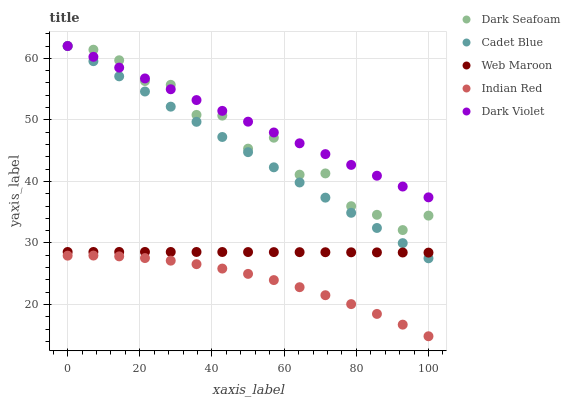Does Indian Red have the minimum area under the curve?
Answer yes or no. Yes. Does Dark Violet have the maximum area under the curve?
Answer yes or no. Yes. Does Cadet Blue have the minimum area under the curve?
Answer yes or no. No. Does Cadet Blue have the maximum area under the curve?
Answer yes or no. No. Is Cadet Blue the smoothest?
Answer yes or no. Yes. Is Dark Seafoam the roughest?
Answer yes or no. Yes. Is Web Maroon the smoothest?
Answer yes or no. No. Is Web Maroon the roughest?
Answer yes or no. No. Does Indian Red have the lowest value?
Answer yes or no. Yes. Does Cadet Blue have the lowest value?
Answer yes or no. No. Does Dark Violet have the highest value?
Answer yes or no. Yes. Does Web Maroon have the highest value?
Answer yes or no. No. Is Indian Red less than Web Maroon?
Answer yes or no. Yes. Is Web Maroon greater than Indian Red?
Answer yes or no. Yes. Does Dark Violet intersect Dark Seafoam?
Answer yes or no. Yes. Is Dark Violet less than Dark Seafoam?
Answer yes or no. No. Is Dark Violet greater than Dark Seafoam?
Answer yes or no. No. Does Indian Red intersect Web Maroon?
Answer yes or no. No. 